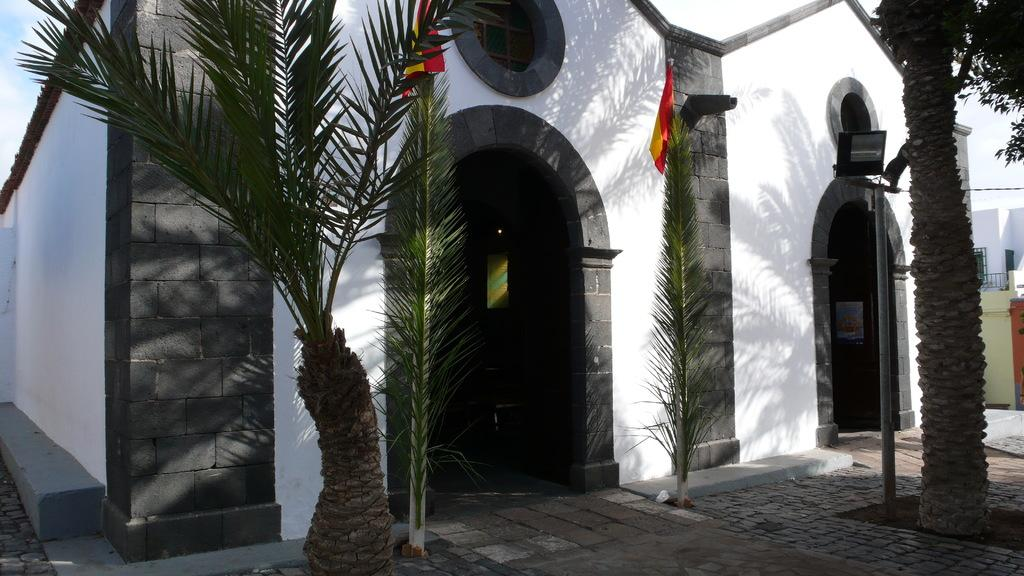What type of structure is visible in the image? There is a building in the image. What type of vegetation is present on either side of the building? Palm trees are present on either side of the building. What is located in the middle of the building? There is a flag in the middle of the building. What can be seen above the building? The sky is visible above the building. How many girls are playing the drum in the image? There are no girls or drums present in the image. 